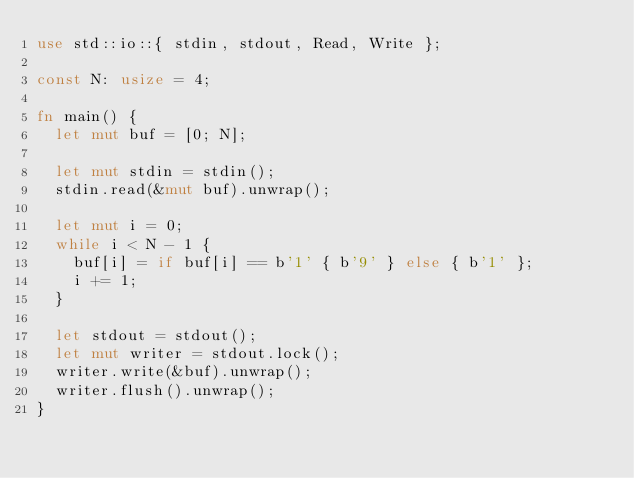Convert code to text. <code><loc_0><loc_0><loc_500><loc_500><_Rust_>use std::io::{ stdin, stdout, Read, Write };

const N: usize = 4;

fn main() {
  let mut buf = [0; N];

  let mut stdin = stdin();
  stdin.read(&mut buf).unwrap();

  let mut i = 0;
  while i < N - 1 {
    buf[i] = if buf[i] == b'1' { b'9' } else { b'1' };
    i += 1;
  }

  let stdout = stdout();
  let mut writer = stdout.lock();
  writer.write(&buf).unwrap();
  writer.flush().unwrap();
}
</code> 